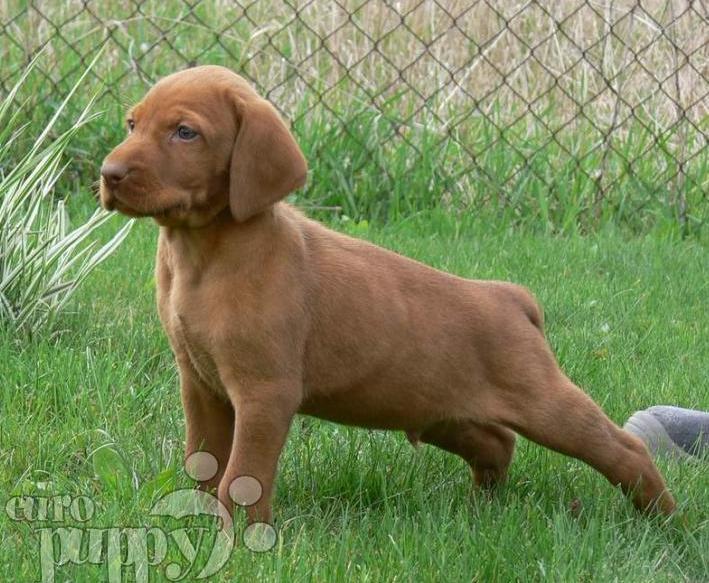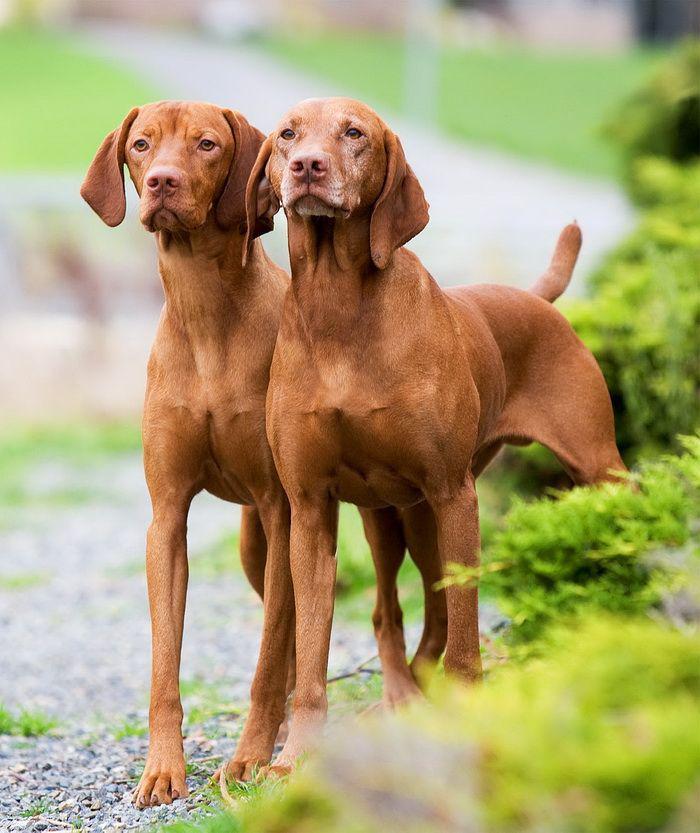The first image is the image on the left, the second image is the image on the right. Assess this claim about the two images: "Each image includes at least one red-orange dog in a standing pose, at least two adult dogs in total are shown, and no other poses are shown.". Correct or not? Answer yes or no. Yes. The first image is the image on the left, the second image is the image on the right. Considering the images on both sides, is "There are two dogs." valid? Answer yes or no. No. 